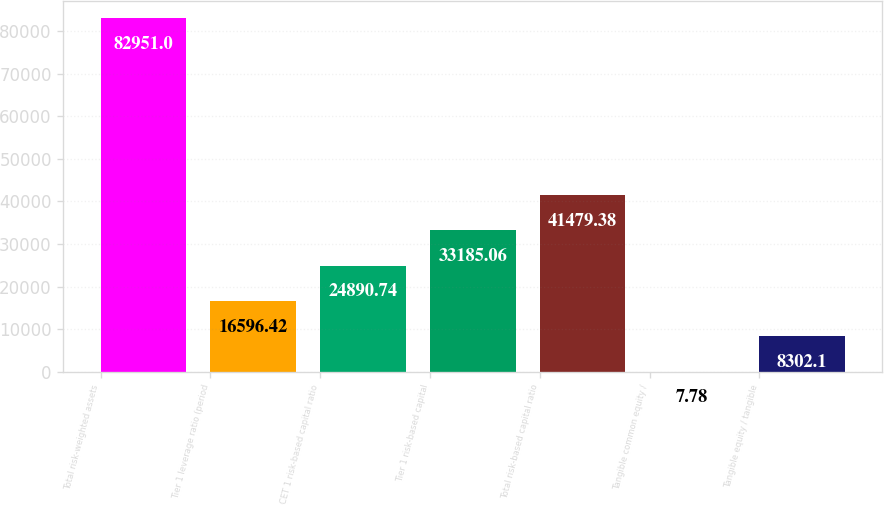<chart> <loc_0><loc_0><loc_500><loc_500><bar_chart><fcel>Total risk-weighted assets<fcel>Tier 1 leverage ratio (period<fcel>CET 1 risk-based capital ratio<fcel>Tier 1 risk-based capital<fcel>Total risk-based capital ratio<fcel>Tangible common equity /<fcel>Tangible equity / tangible<nl><fcel>82951<fcel>16596.4<fcel>24890.7<fcel>33185.1<fcel>41479.4<fcel>7.78<fcel>8302.1<nl></chart> 